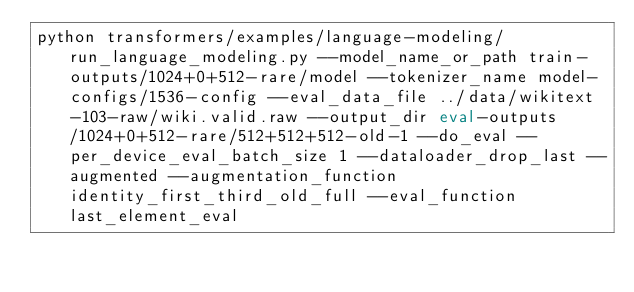Convert code to text. <code><loc_0><loc_0><loc_500><loc_500><_Bash_>python transformers/examples/language-modeling/run_language_modeling.py --model_name_or_path train-outputs/1024+0+512-rare/model --tokenizer_name model-configs/1536-config --eval_data_file ../data/wikitext-103-raw/wiki.valid.raw --output_dir eval-outputs/1024+0+512-rare/512+512+512-old-1 --do_eval --per_device_eval_batch_size 1 --dataloader_drop_last --augmented --augmentation_function identity_first_third_old_full --eval_function last_element_eval</code> 